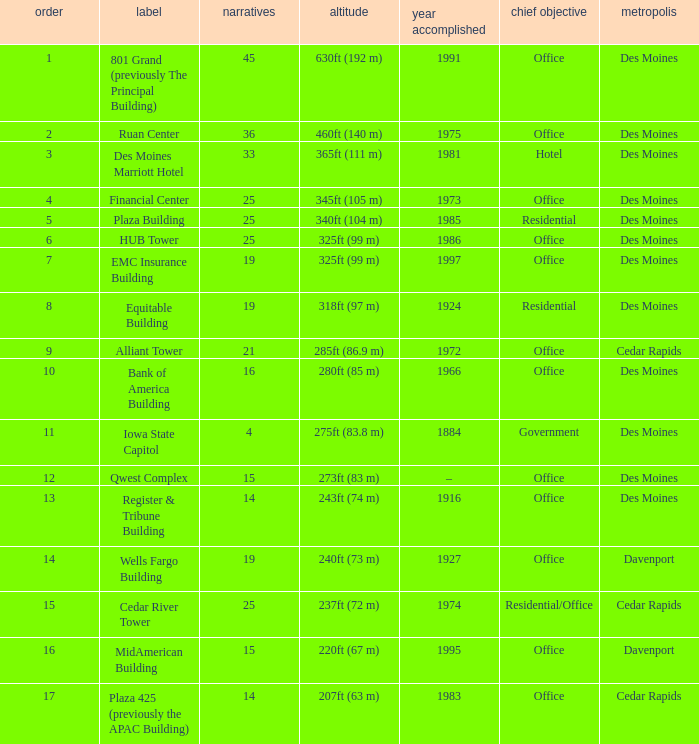What is the total stories that rank number 10? 1.0. 